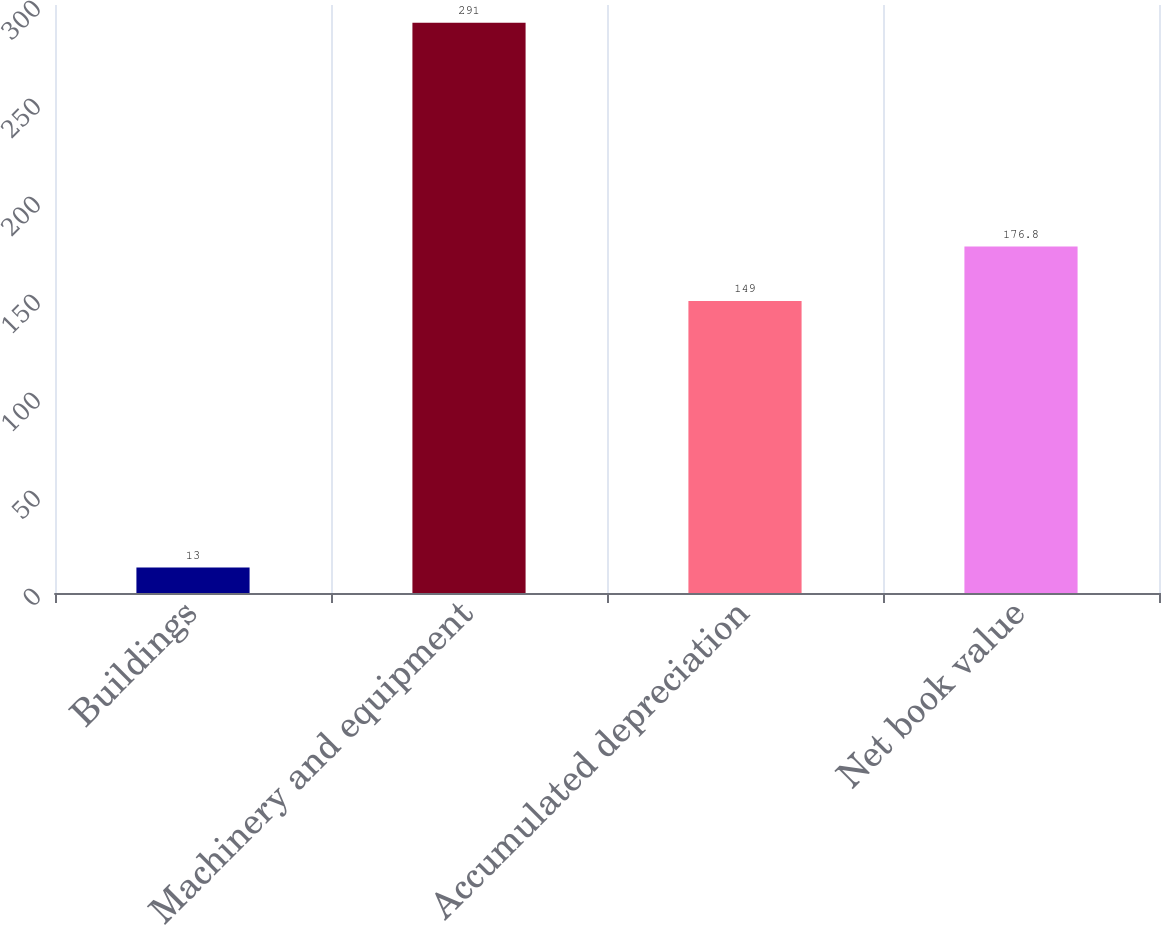<chart> <loc_0><loc_0><loc_500><loc_500><bar_chart><fcel>Buildings<fcel>Machinery and equipment<fcel>Accumulated depreciation<fcel>Net book value<nl><fcel>13<fcel>291<fcel>149<fcel>176.8<nl></chart> 